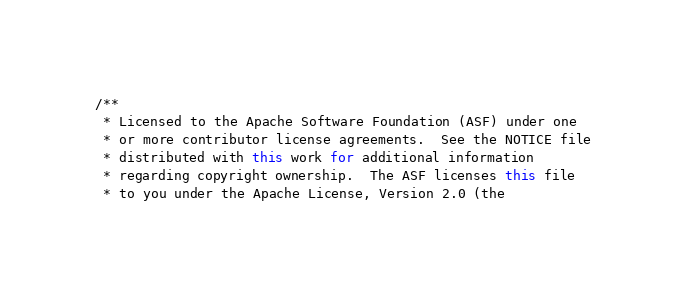<code> <loc_0><loc_0><loc_500><loc_500><_Java_>/**
 * Licensed to the Apache Software Foundation (ASF) under one
 * or more contributor license agreements.  See the NOTICE file
 * distributed with this work for additional information
 * regarding copyright ownership.  The ASF licenses this file
 * to you under the Apache License, Version 2.0 (the</code> 